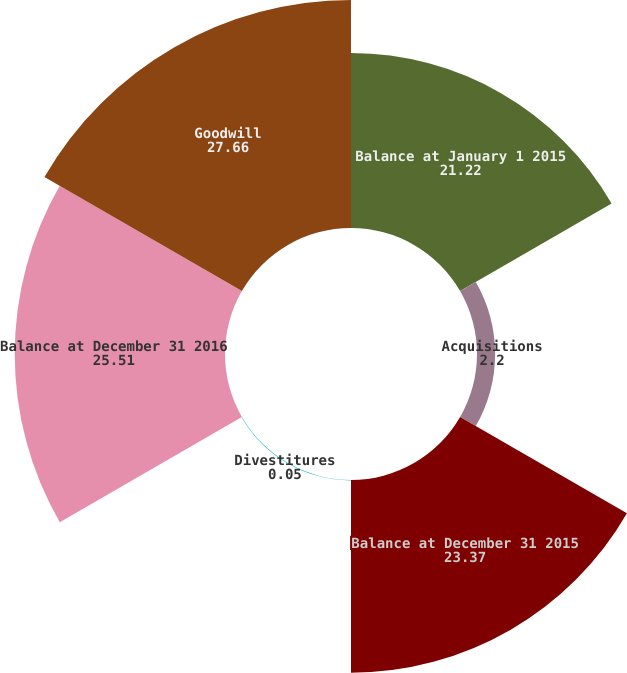Convert chart to OTSL. <chart><loc_0><loc_0><loc_500><loc_500><pie_chart><fcel>Balance at January 1 2015<fcel>Acquisitions<fcel>Balance at December 31 2015<fcel>Divestitures<fcel>Balance at December 31 2016<fcel>Goodwill<nl><fcel>21.22%<fcel>2.2%<fcel>23.37%<fcel>0.05%<fcel>25.51%<fcel>27.66%<nl></chart> 